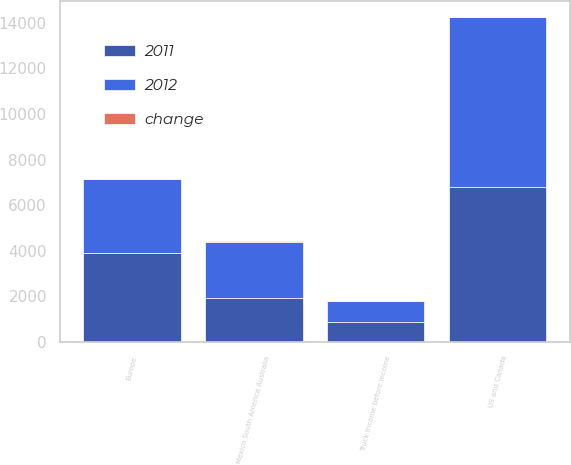<chart> <loc_0><loc_0><loc_500><loc_500><stacked_bar_chart><ecel><fcel>US and Canada<fcel>Europe<fcel>Mexico South America Australia<fcel>Truck income before income<nl><fcel>2012<fcel>7467.8<fcel>3217.1<fcel>2446.6<fcel>920.4<nl><fcel>2011<fcel>6776.4<fcel>3914.6<fcel>1939.7<fcel>864.7<nl><fcel>change<fcel>10<fcel>18<fcel>26<fcel>6<nl></chart> 